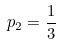<formula> <loc_0><loc_0><loc_500><loc_500>p _ { 2 } = \frac { 1 } { 3 }</formula> 